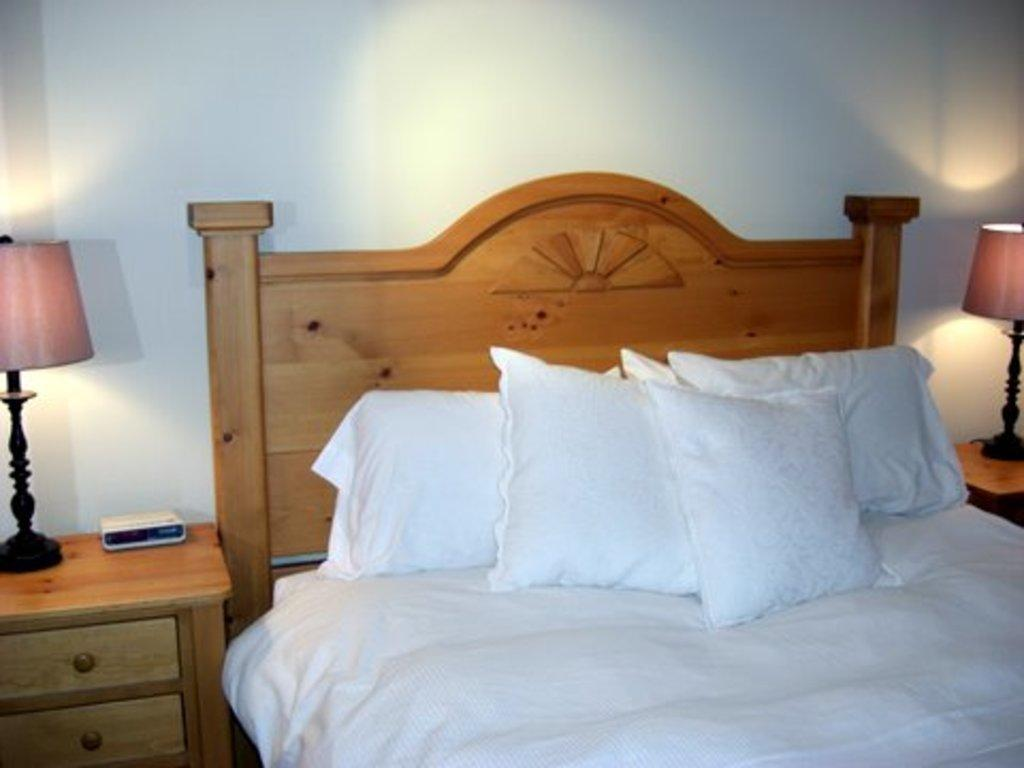What piece of furniture is present in the image? There is a bed in the image. What is placed on the bed? There are pillows on the bed. What type of lighting is present in the image? There are lamps on tables in the image. What can be found on the tables besides lamps? There are drawers associated with the tables. What color is the wall in the image? The wall in the image is white. What object is placed on one of the tables? There is a box on one of the tables. What type of button can be seen on the beast in the image? There is no beast or button present in the image. How many bombs are visible on the bed in the image? There are no bombs present in the image; it features a bed with pillows and a box on a table. 